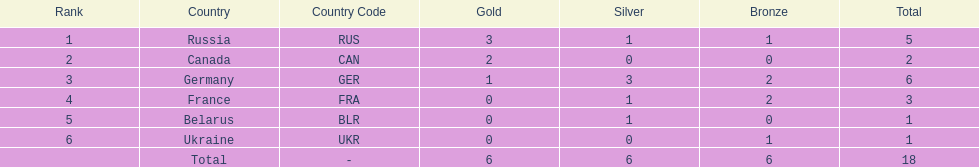What was the total number of silver medals awarded to the french and the germans in the 1994 winter olympic biathlon? 4. 